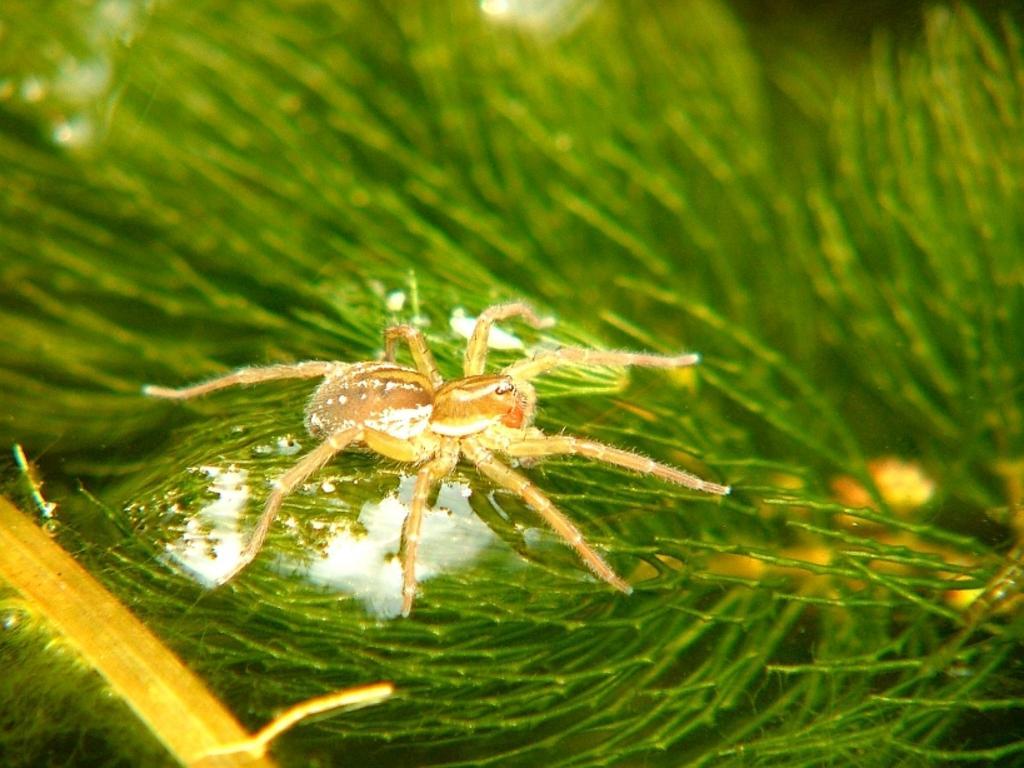Could you give a brief overview of what you see in this image? Here we can see an insect on a green color surface. 